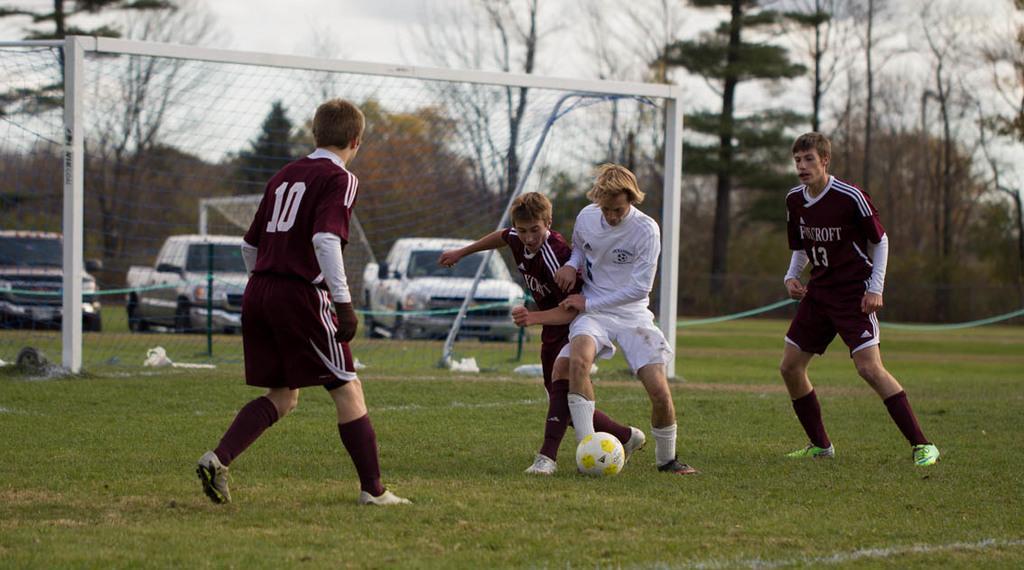In one or two sentences, can you explain what this image depicts? In the middle 4 people are playing the football behind them there is a car and trees. 